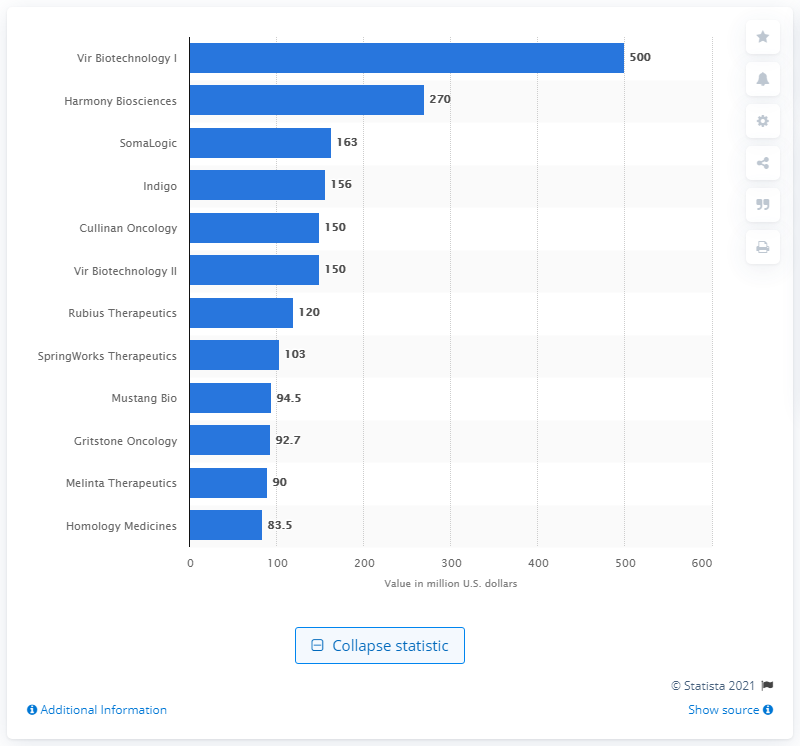Specify some key components in this picture. Vir Biotechnology was financed to the tune of 500 million dollars. 